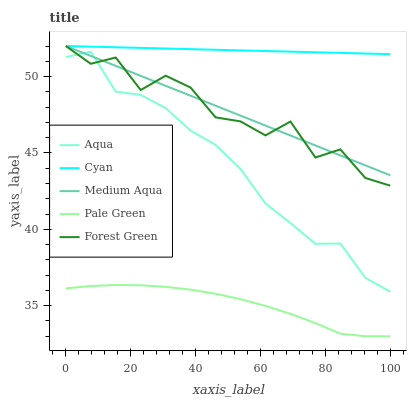Does Pale Green have the minimum area under the curve?
Answer yes or no. Yes. Does Cyan have the maximum area under the curve?
Answer yes or no. Yes. Does Forest Green have the minimum area under the curve?
Answer yes or no. No. Does Forest Green have the maximum area under the curve?
Answer yes or no. No. Is Cyan the smoothest?
Answer yes or no. Yes. Is Forest Green the roughest?
Answer yes or no. Yes. Is Forest Green the smoothest?
Answer yes or no. No. Is Cyan the roughest?
Answer yes or no. No. Does Pale Green have the lowest value?
Answer yes or no. Yes. Does Forest Green have the lowest value?
Answer yes or no. No. Does Forest Green have the highest value?
Answer yes or no. Yes. Does Pale Green have the highest value?
Answer yes or no. No. Is Aqua less than Cyan?
Answer yes or no. Yes. Is Medium Aqua greater than Pale Green?
Answer yes or no. Yes. Does Forest Green intersect Medium Aqua?
Answer yes or no. Yes. Is Forest Green less than Medium Aqua?
Answer yes or no. No. Is Forest Green greater than Medium Aqua?
Answer yes or no. No. Does Aqua intersect Cyan?
Answer yes or no. No. 